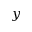<formula> <loc_0><loc_0><loc_500><loc_500>y</formula> 